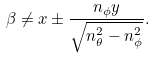<formula> <loc_0><loc_0><loc_500><loc_500>\beta \neq x \pm \frac { n _ { \phi } y } { \sqrt { n _ { \theta } ^ { 2 } - n _ { \phi } ^ { 2 } } } .</formula> 